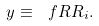Convert formula to latex. <formula><loc_0><loc_0><loc_500><loc_500>\ y \equiv \ f { R } { R _ { i } } .</formula> 